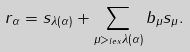Convert formula to latex. <formula><loc_0><loc_0><loc_500><loc_500>r _ { \alpha } = s _ { \lambda ( \alpha ) } + \sum _ { \mu > _ { l e x } \lambda ( \alpha ) } b _ { \mu } s _ { \mu } .</formula> 